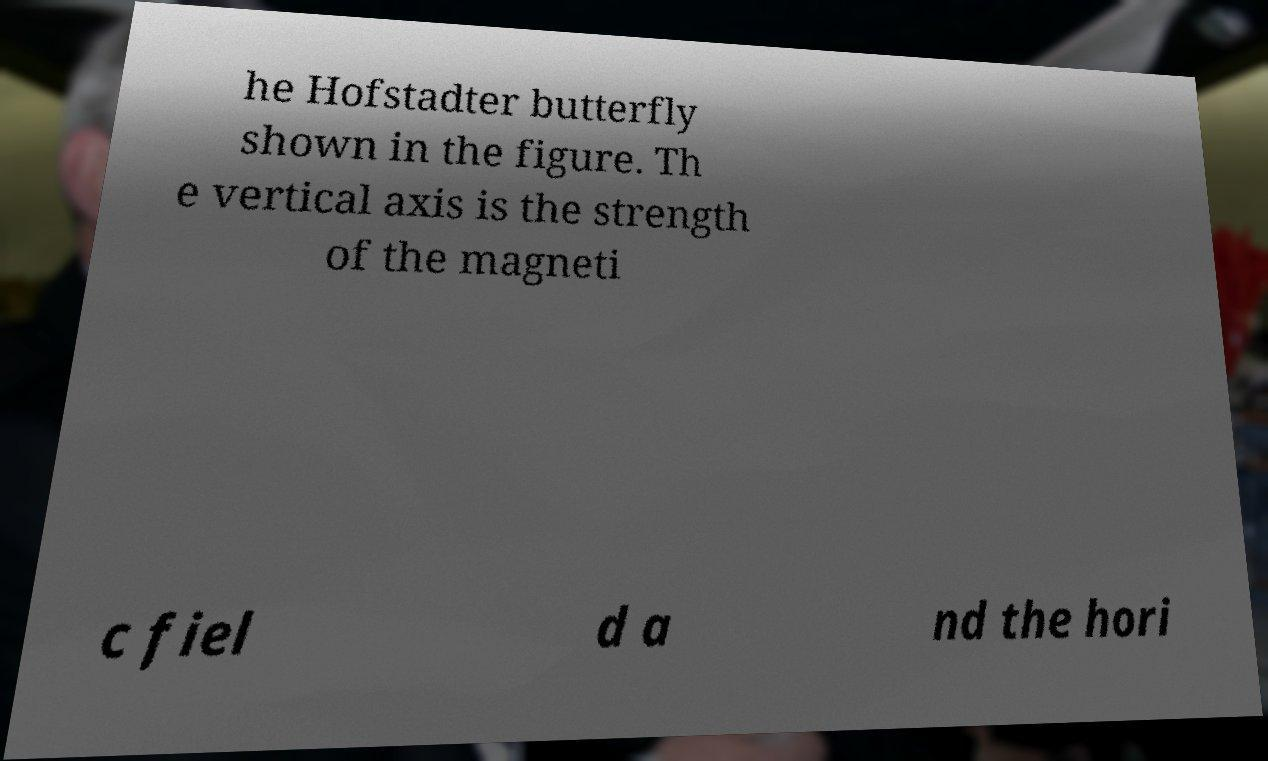Can you accurately transcribe the text from the provided image for me? he Hofstadter butterfly shown in the figure. Th e vertical axis is the strength of the magneti c fiel d a nd the hori 